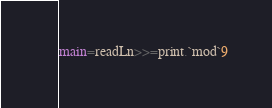Convert code to text. <code><loc_0><loc_0><loc_500><loc_500><_Haskell_>main=readLn>>=print.`mod`9</code> 